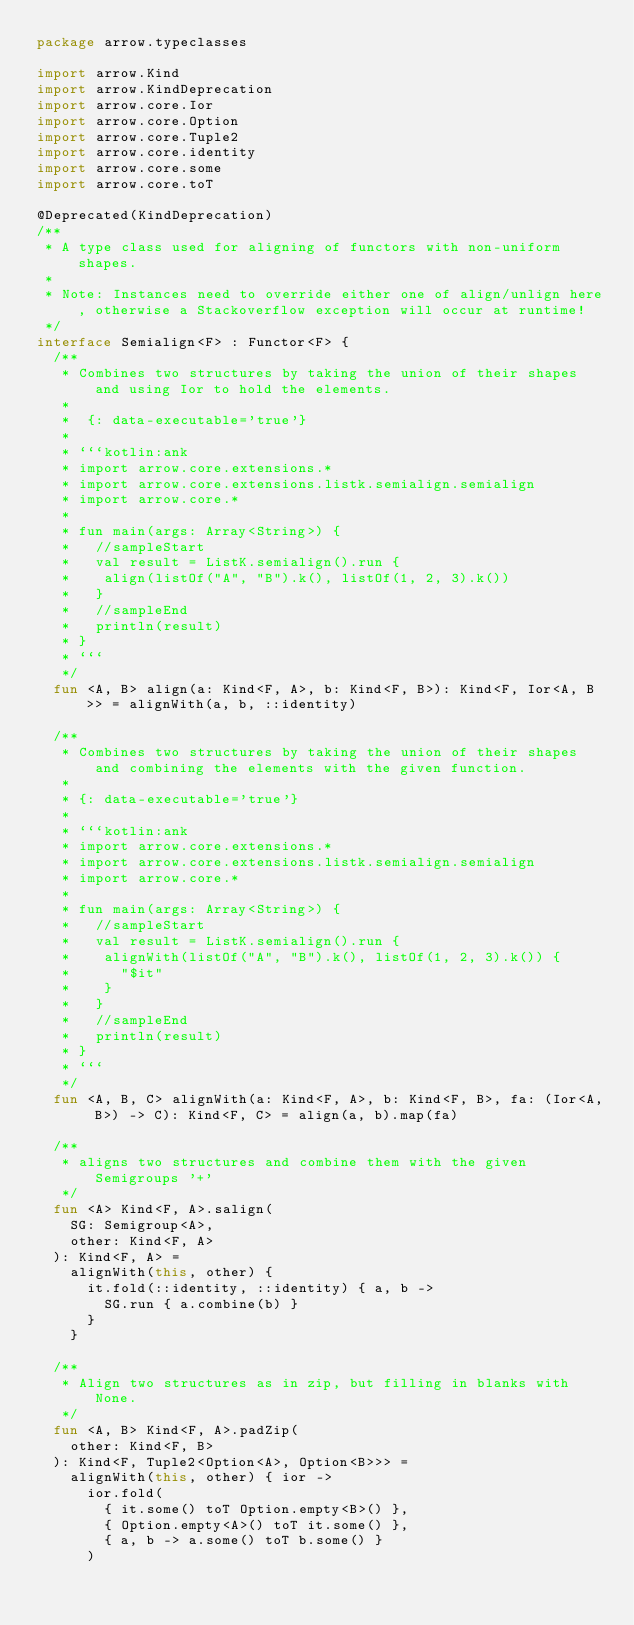<code> <loc_0><loc_0><loc_500><loc_500><_Kotlin_>package arrow.typeclasses

import arrow.Kind
import arrow.KindDeprecation
import arrow.core.Ior
import arrow.core.Option
import arrow.core.Tuple2
import arrow.core.identity
import arrow.core.some
import arrow.core.toT

@Deprecated(KindDeprecation)
/**
 * A type class used for aligning of functors with non-uniform shapes.
 *
 * Note: Instances need to override either one of align/unlign here, otherwise a Stackoverflow exception will occur at runtime!
 */
interface Semialign<F> : Functor<F> {
  /**
   * Combines two structures by taking the union of their shapes and using Ior to hold the elements.
   *
   *  {: data-executable='true'}
   *
   * ```kotlin:ank
   * import arrow.core.extensions.*
   * import arrow.core.extensions.listk.semialign.semialign
   * import arrow.core.*
   *
   * fun main(args: Array<String>) {
   *   //sampleStart
   *   val result = ListK.semialign().run {
   *    align(listOf("A", "B").k(), listOf(1, 2, 3).k())
   *   }
   *   //sampleEnd
   *   println(result)
   * }
   * ```
   */
  fun <A, B> align(a: Kind<F, A>, b: Kind<F, B>): Kind<F, Ior<A, B>> = alignWith(a, b, ::identity)

  /**
   * Combines two structures by taking the union of their shapes and combining the elements with the given function.
   *
   * {: data-executable='true'}
   *
   * ```kotlin:ank
   * import arrow.core.extensions.*
   * import arrow.core.extensions.listk.semialign.semialign
   * import arrow.core.*
   *
   * fun main(args: Array<String>) {
   *   //sampleStart
   *   val result = ListK.semialign().run {
   *    alignWith(listOf("A", "B").k(), listOf(1, 2, 3).k()) {
   *      "$it"
   *    }
   *   }
   *   //sampleEnd
   *   println(result)
   * }
   * ```
   */
  fun <A, B, C> alignWith(a: Kind<F, A>, b: Kind<F, B>, fa: (Ior<A, B>) -> C): Kind<F, C> = align(a, b).map(fa)

  /**
   * aligns two structures and combine them with the given Semigroups '+'
   */
  fun <A> Kind<F, A>.salign(
    SG: Semigroup<A>,
    other: Kind<F, A>
  ): Kind<F, A> =
    alignWith(this, other) {
      it.fold(::identity, ::identity) { a, b ->
        SG.run { a.combine(b) }
      }
    }

  /**
   * Align two structures as in zip, but filling in blanks with None.
   */
  fun <A, B> Kind<F, A>.padZip(
    other: Kind<F, B>
  ): Kind<F, Tuple2<Option<A>, Option<B>>> =
    alignWith(this, other) { ior ->
      ior.fold(
        { it.some() toT Option.empty<B>() },
        { Option.empty<A>() toT it.some() },
        { a, b -> a.some() toT b.some() }
      )</code> 